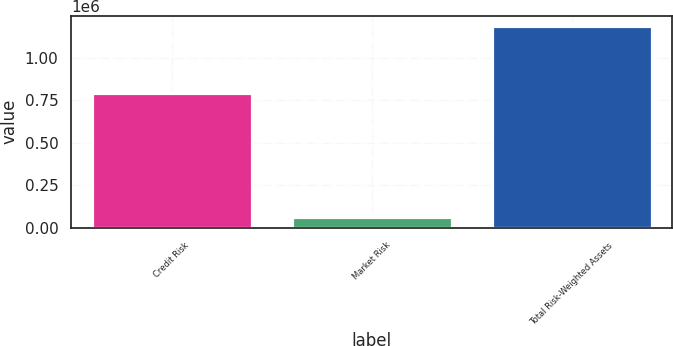Convert chart to OTSL. <chart><loc_0><loc_0><loc_500><loc_500><bar_chart><fcel>Credit Risk<fcel>Market Risk<fcel>Total Risk-Weighted Assets<nl><fcel>796399<fcel>64006<fcel>1.18968e+06<nl></chart> 